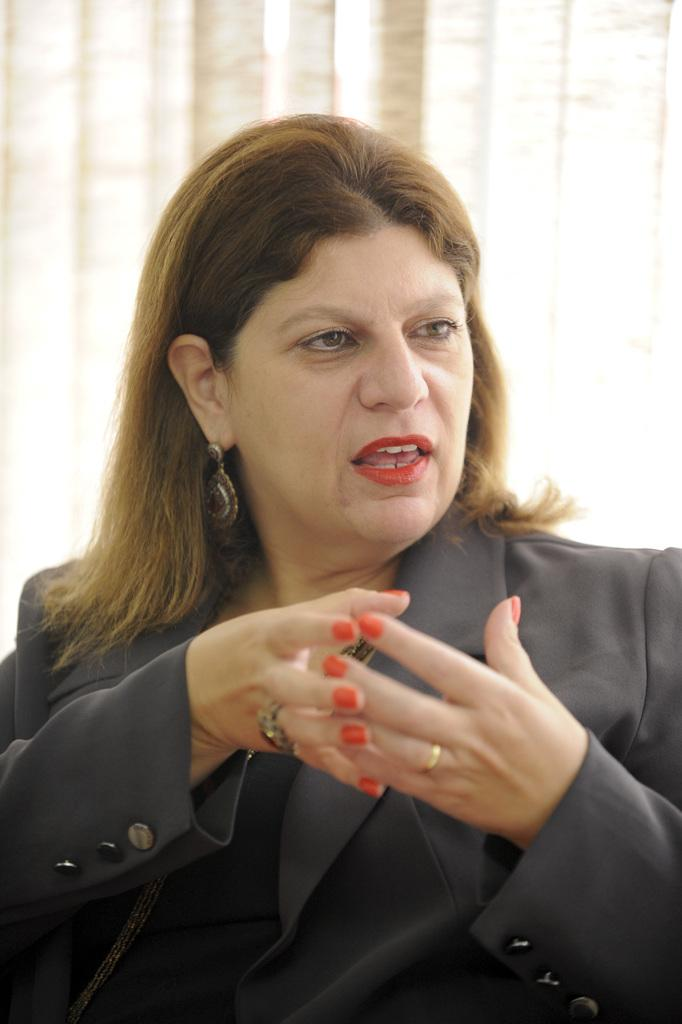Who is present in the picture? There is a woman in the picture. What is the woman wearing in the picture? The woman is wearing a black suit in the picture. Can you describe any accessories the woman is wearing? The woman is wearing earrings in the picture. How many ants can be seen crawling on the woman's earrings in the picture? There are no ants present in the picture, and therefore none can be seen crawling on the woman's earrings. 